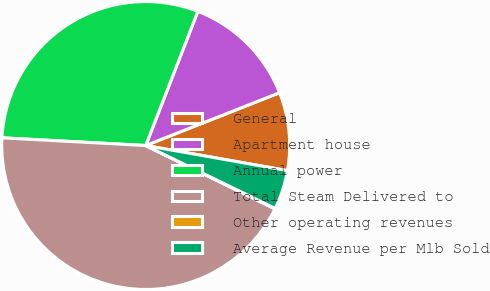Convert chart. <chart><loc_0><loc_0><loc_500><loc_500><pie_chart><fcel>General<fcel>Apartment house<fcel>Annual power<fcel>Total Steam Delivered to<fcel>Other operating revenues<fcel>Average Revenue per Mlb Sold<nl><fcel>8.77%<fcel>13.12%<fcel>30.05%<fcel>43.6%<fcel>0.06%<fcel>4.41%<nl></chart> 